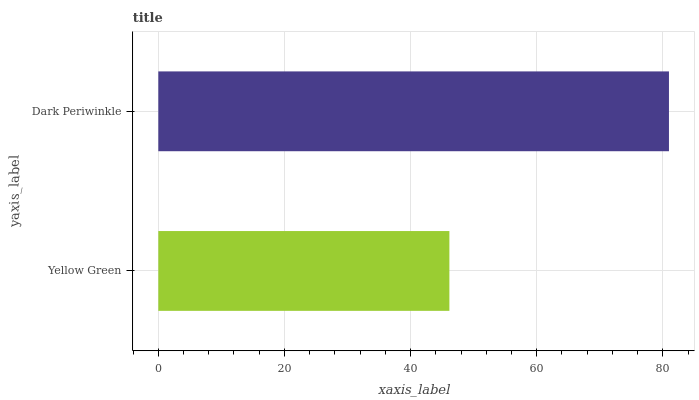Is Yellow Green the minimum?
Answer yes or no. Yes. Is Dark Periwinkle the maximum?
Answer yes or no. Yes. Is Dark Periwinkle the minimum?
Answer yes or no. No. Is Dark Periwinkle greater than Yellow Green?
Answer yes or no. Yes. Is Yellow Green less than Dark Periwinkle?
Answer yes or no. Yes. Is Yellow Green greater than Dark Periwinkle?
Answer yes or no. No. Is Dark Periwinkle less than Yellow Green?
Answer yes or no. No. Is Dark Periwinkle the high median?
Answer yes or no. Yes. Is Yellow Green the low median?
Answer yes or no. Yes. Is Yellow Green the high median?
Answer yes or no. No. Is Dark Periwinkle the low median?
Answer yes or no. No. 